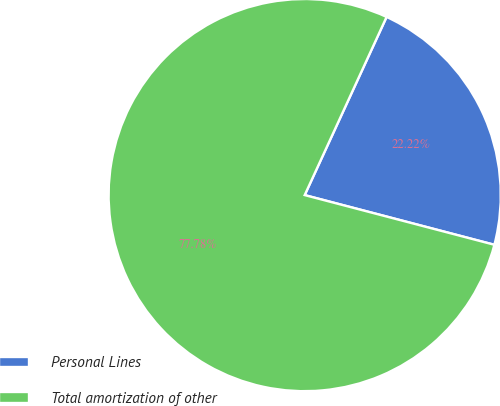<chart> <loc_0><loc_0><loc_500><loc_500><pie_chart><fcel>Personal Lines<fcel>Total amortization of other<nl><fcel>22.22%<fcel>77.78%<nl></chart> 